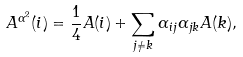Convert formula to latex. <formula><loc_0><loc_0><loc_500><loc_500>A ^ { \alpha ^ { 2 } } ( i ) = \frac { 1 } { 4 } A ( i ) + \sum _ { j \neq k } \alpha _ { i j } \alpha _ { j k } A ( k ) ,</formula> 